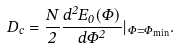<formula> <loc_0><loc_0><loc_500><loc_500>D _ { c } = \frac { N } { 2 } \frac { d ^ { 2 } E _ { 0 } ( \Phi ) } { d \Phi ^ { 2 } } | _ { \Phi = \Phi _ { \min } } .</formula> 